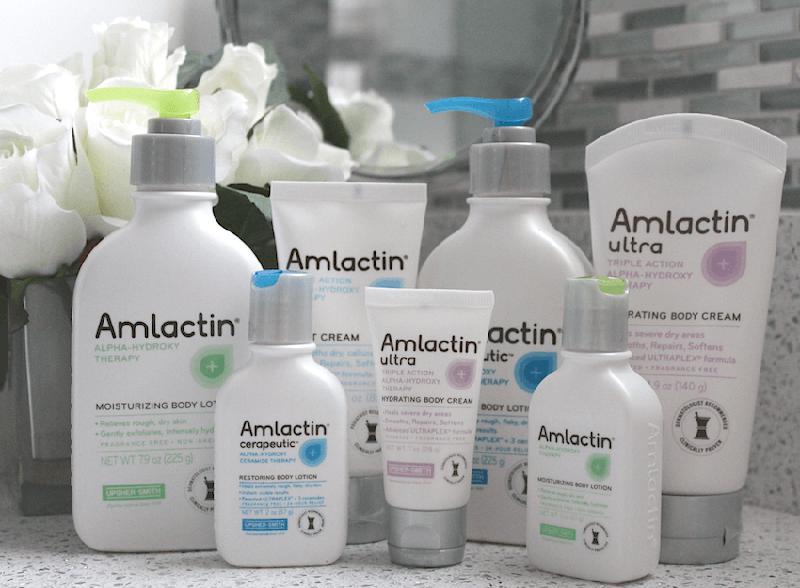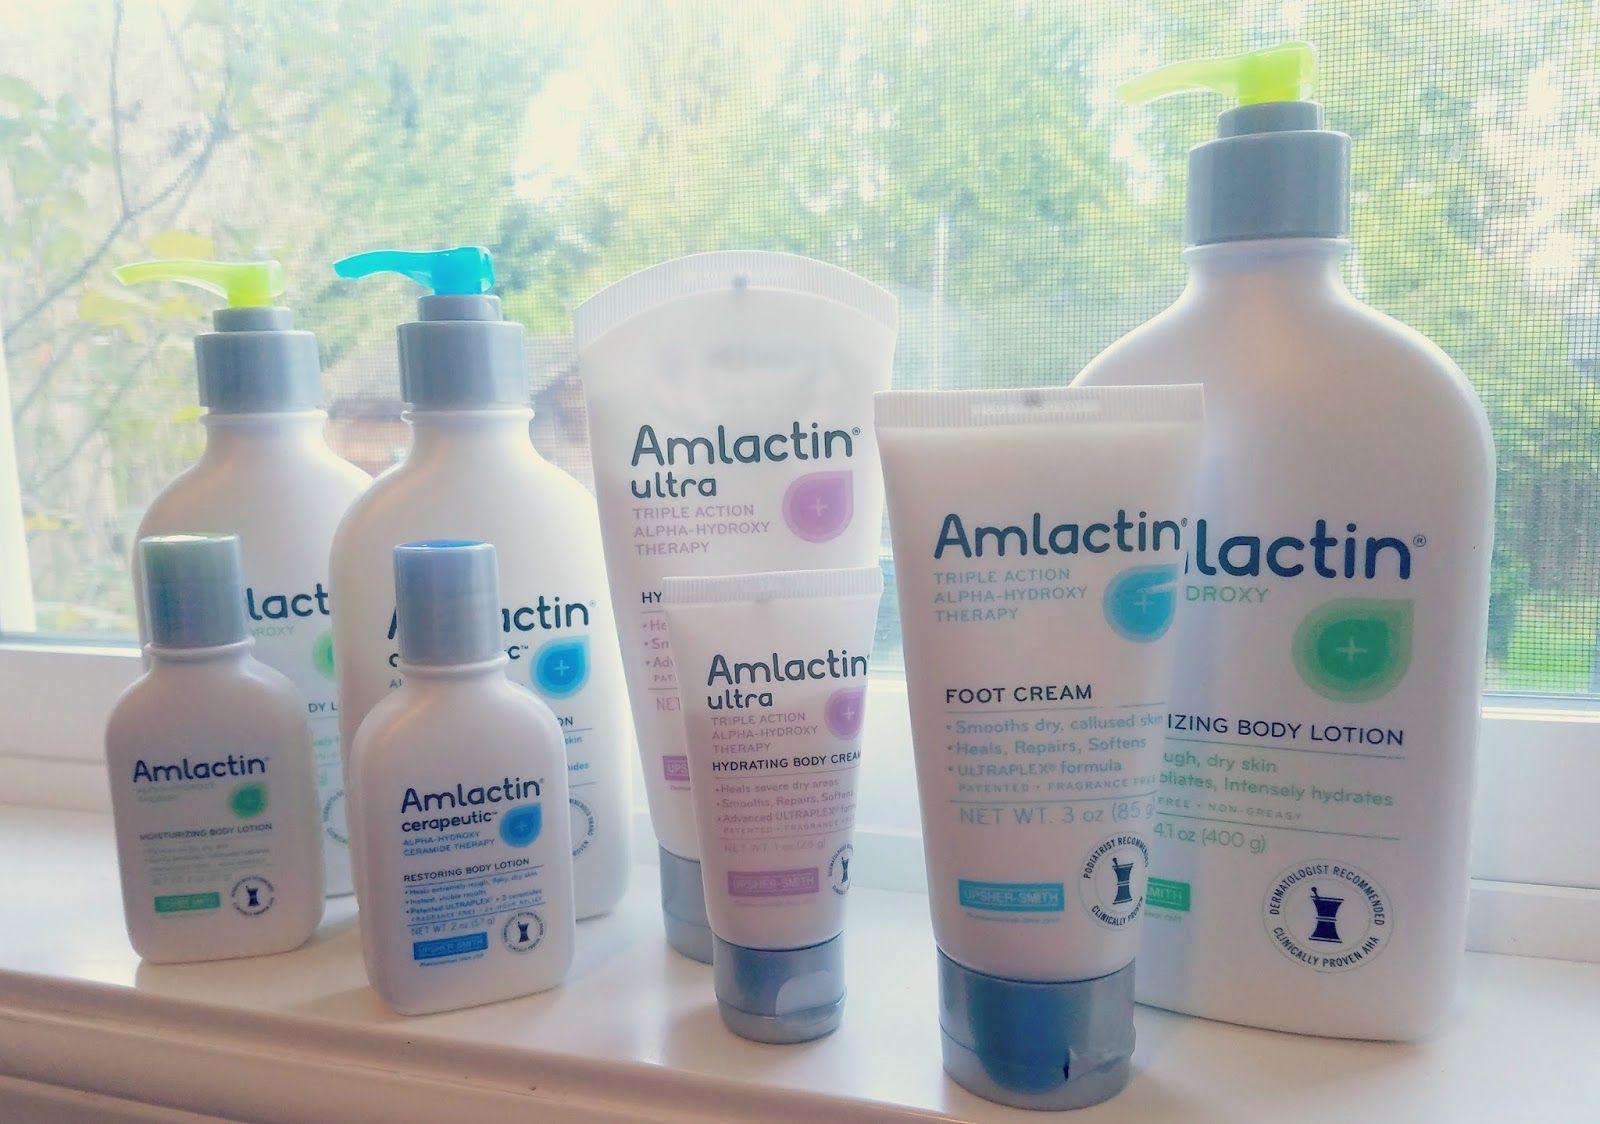The first image is the image on the left, the second image is the image on the right. Considering the images on both sides, is "The left image contains exactly three bottles, all of the same size and shape." valid? Answer yes or no. No. 